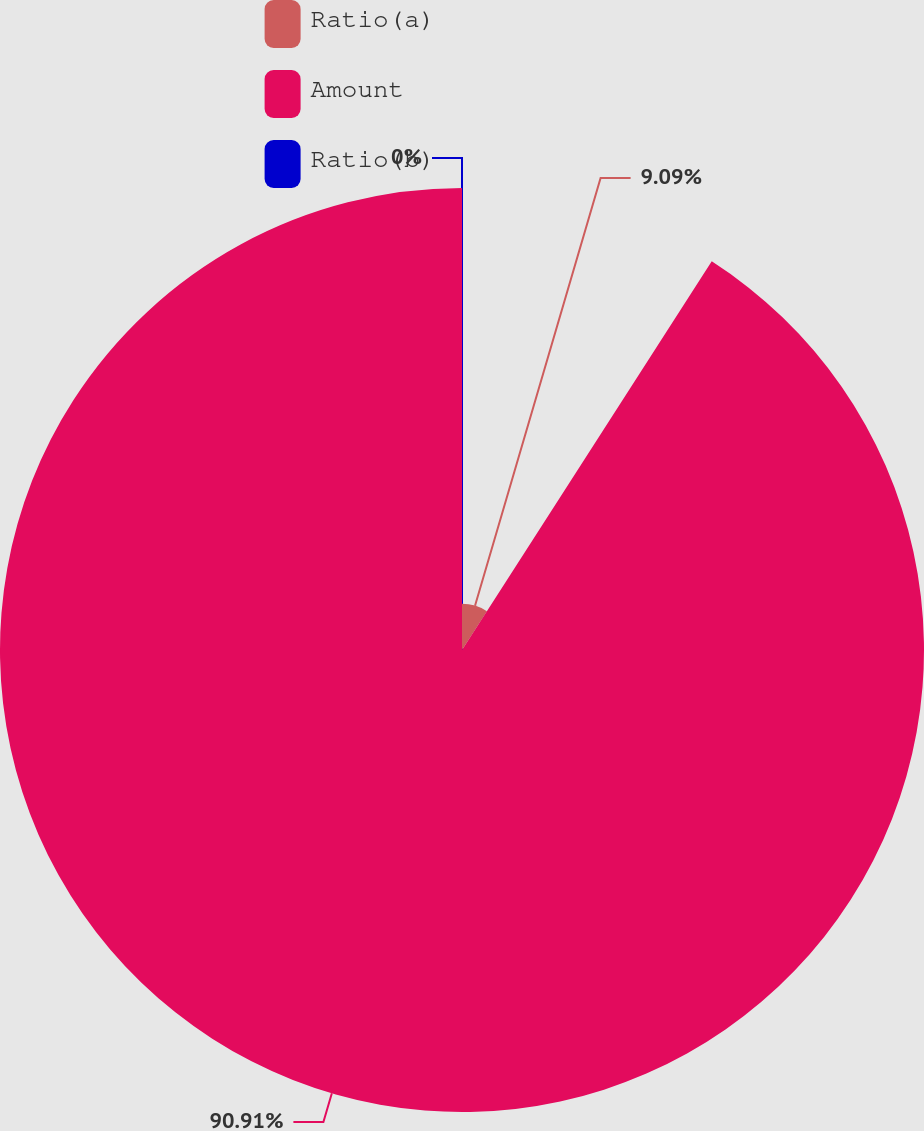Convert chart to OTSL. <chart><loc_0><loc_0><loc_500><loc_500><pie_chart><fcel>Ratio(a)<fcel>Amount<fcel>Ratio(b)<nl><fcel>9.09%<fcel>90.91%<fcel>0.0%<nl></chart> 